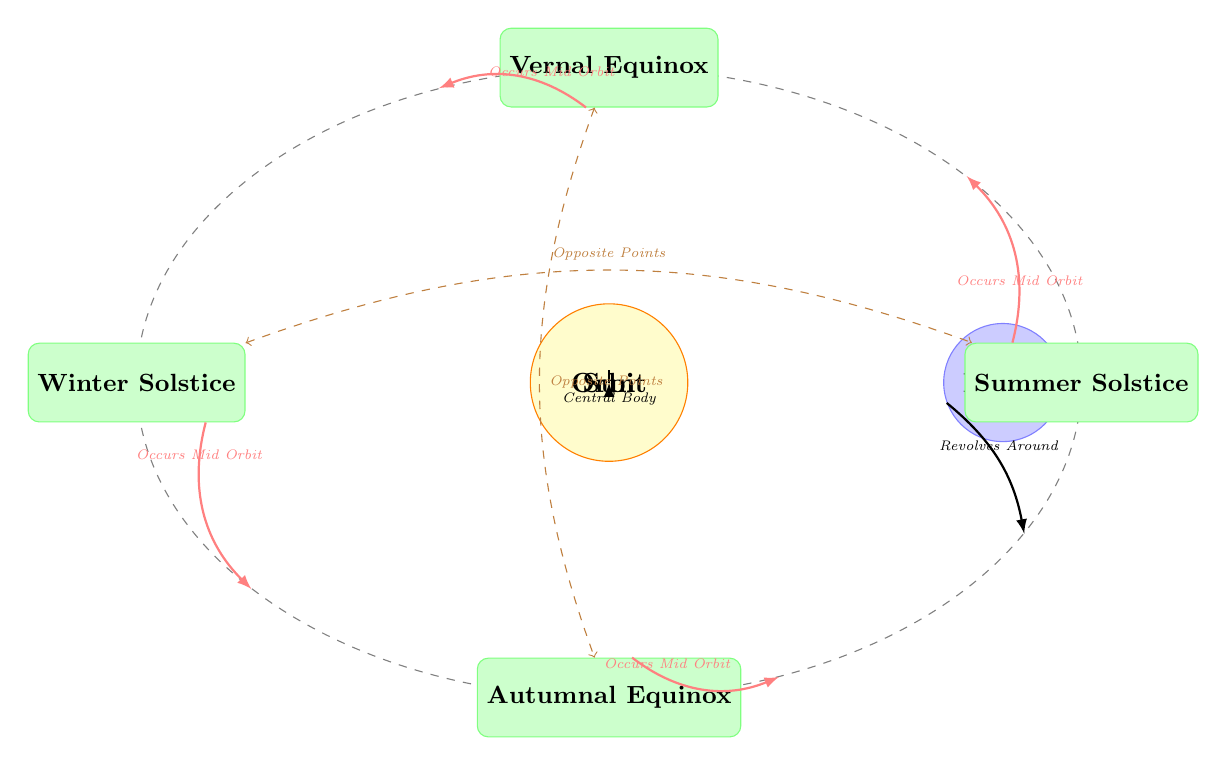What is the central body in this diagram? The diagram clearly identifies the Sun as the central body, indicated by its positioning at the center of the diagram with the label "Sun".
Answer: Sun How many seasonal events are represented in the diagram? The diagram displays four seasonal events: Winter Solstice, Summer Solstice, Vernal Equinox, and Autumnal Equinox. Counting these gives a total of four seasonal events.
Answer: 4 Which seasonal event occurs at the top of the diagram? The Vernal Equinox is positioned at the top of the diagram, as indicated by its placement directly above the central orbit.
Answer: Vernal Equinox What relationship do the Winter and Summer Solstices share in the diagram? The diagram shows a dashed brown arrow between the Winter Solstice and Summer Solstice labeled "Opposite Points", indicating their relationship as being opposite points in Earth's orbit.
Answer: Opposite Points Which direction does the Earth revolve around the Sun according to the diagram? The diagram features an arrow from Earth to its orbit, labeled "Revolves Around", which indicates that the Earth revolves in a counter-clockwise direction around the Sun.
Answer: Counter-clockwise What label is given to the path representing Earth's orbit? The orbit of Earth around the Sun is labeled simply as "Orbit", which is clearly marked in an elliptical path around the Sun in the diagram.
Answer: Orbit Which equinox is located at the bottom of the diagram? The Autumnal Equinox is positioned at the bottom of the diagram, below the central orbit represented with its respective label.
Answer: Autumnal Equinox What color represents the planets in the diagram? The planets in the diagram are represented by a blue color scheme, indicated by the dashed border and the filled circle for Earth drawn in blue!20.
Answer: Blue How are seasonal events connected to Earth's orbit as illustrated in the diagram? The seasonal events are connected to Earth’s orbit via red arrows labeled "Occurs Mid Orbit", showing that these events occur at various positions in the orbit throughout the year.
Answer: Occurs Mid Orbit 